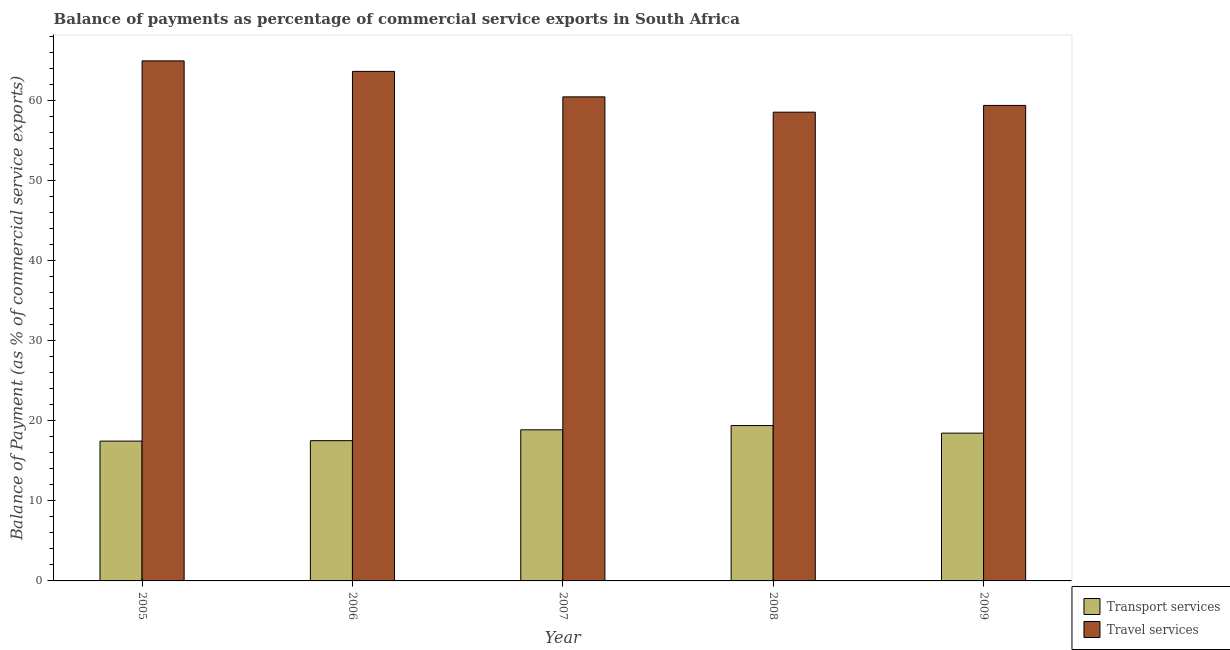Are the number of bars per tick equal to the number of legend labels?
Offer a very short reply. Yes. How many bars are there on the 4th tick from the right?
Offer a terse response. 2. What is the balance of payments of transport services in 2006?
Ensure brevity in your answer.  17.52. Across all years, what is the maximum balance of payments of travel services?
Ensure brevity in your answer.  64.96. Across all years, what is the minimum balance of payments of transport services?
Keep it short and to the point. 17.47. In which year was the balance of payments of travel services maximum?
Offer a terse response. 2005. What is the total balance of payments of travel services in the graph?
Your answer should be very brief. 307.03. What is the difference between the balance of payments of transport services in 2006 and that in 2009?
Make the answer very short. -0.94. What is the difference between the balance of payments of travel services in 2009 and the balance of payments of transport services in 2007?
Keep it short and to the point. -1.07. What is the average balance of payments of transport services per year?
Your response must be concise. 18.35. In the year 2009, what is the difference between the balance of payments of travel services and balance of payments of transport services?
Offer a very short reply. 0. In how many years, is the balance of payments of transport services greater than 10 %?
Provide a short and direct response. 5. What is the ratio of the balance of payments of travel services in 2005 to that in 2007?
Make the answer very short. 1.07. Is the balance of payments of travel services in 2006 less than that in 2008?
Keep it short and to the point. No. What is the difference between the highest and the second highest balance of payments of transport services?
Ensure brevity in your answer.  0.53. What is the difference between the highest and the lowest balance of payments of travel services?
Keep it short and to the point. 6.41. Is the sum of the balance of payments of travel services in 2005 and 2008 greater than the maximum balance of payments of transport services across all years?
Your answer should be compact. Yes. What does the 2nd bar from the left in 2005 represents?
Your response must be concise. Travel services. What does the 2nd bar from the right in 2005 represents?
Ensure brevity in your answer.  Transport services. What is the title of the graph?
Ensure brevity in your answer.  Balance of payments as percentage of commercial service exports in South Africa. Does "Diarrhea" appear as one of the legend labels in the graph?
Provide a succinct answer. No. What is the label or title of the X-axis?
Provide a short and direct response. Year. What is the label or title of the Y-axis?
Make the answer very short. Balance of Payment (as % of commercial service exports). What is the Balance of Payment (as % of commercial service exports) of Transport services in 2005?
Offer a very short reply. 17.47. What is the Balance of Payment (as % of commercial service exports) of Travel services in 2005?
Offer a very short reply. 64.96. What is the Balance of Payment (as % of commercial service exports) of Transport services in 2006?
Provide a succinct answer. 17.52. What is the Balance of Payment (as % of commercial service exports) of Travel services in 2006?
Your answer should be compact. 63.65. What is the Balance of Payment (as % of commercial service exports) of Transport services in 2007?
Make the answer very short. 18.88. What is the Balance of Payment (as % of commercial service exports) of Travel services in 2007?
Your answer should be very brief. 60.46. What is the Balance of Payment (as % of commercial service exports) in Transport services in 2008?
Offer a terse response. 19.41. What is the Balance of Payment (as % of commercial service exports) of Travel services in 2008?
Offer a terse response. 58.55. What is the Balance of Payment (as % of commercial service exports) in Transport services in 2009?
Provide a succinct answer. 18.46. What is the Balance of Payment (as % of commercial service exports) in Travel services in 2009?
Provide a short and direct response. 59.4. Across all years, what is the maximum Balance of Payment (as % of commercial service exports) in Transport services?
Give a very brief answer. 19.41. Across all years, what is the maximum Balance of Payment (as % of commercial service exports) of Travel services?
Your answer should be compact. 64.96. Across all years, what is the minimum Balance of Payment (as % of commercial service exports) in Transport services?
Your answer should be very brief. 17.47. Across all years, what is the minimum Balance of Payment (as % of commercial service exports) in Travel services?
Make the answer very short. 58.55. What is the total Balance of Payment (as % of commercial service exports) in Transport services in the graph?
Give a very brief answer. 91.73. What is the total Balance of Payment (as % of commercial service exports) in Travel services in the graph?
Make the answer very short. 307.03. What is the difference between the Balance of Payment (as % of commercial service exports) in Transport services in 2005 and that in 2006?
Ensure brevity in your answer.  -0.05. What is the difference between the Balance of Payment (as % of commercial service exports) in Travel services in 2005 and that in 2006?
Give a very brief answer. 1.31. What is the difference between the Balance of Payment (as % of commercial service exports) in Transport services in 2005 and that in 2007?
Keep it short and to the point. -1.41. What is the difference between the Balance of Payment (as % of commercial service exports) in Travel services in 2005 and that in 2007?
Your answer should be very brief. 4.5. What is the difference between the Balance of Payment (as % of commercial service exports) of Transport services in 2005 and that in 2008?
Offer a terse response. -1.94. What is the difference between the Balance of Payment (as % of commercial service exports) in Travel services in 2005 and that in 2008?
Provide a succinct answer. 6.41. What is the difference between the Balance of Payment (as % of commercial service exports) of Transport services in 2005 and that in 2009?
Your answer should be very brief. -0.99. What is the difference between the Balance of Payment (as % of commercial service exports) of Travel services in 2005 and that in 2009?
Keep it short and to the point. 5.56. What is the difference between the Balance of Payment (as % of commercial service exports) in Transport services in 2006 and that in 2007?
Make the answer very short. -1.36. What is the difference between the Balance of Payment (as % of commercial service exports) of Travel services in 2006 and that in 2007?
Make the answer very short. 3.18. What is the difference between the Balance of Payment (as % of commercial service exports) of Transport services in 2006 and that in 2008?
Your answer should be compact. -1.89. What is the difference between the Balance of Payment (as % of commercial service exports) in Travel services in 2006 and that in 2008?
Your answer should be compact. 5.1. What is the difference between the Balance of Payment (as % of commercial service exports) in Transport services in 2006 and that in 2009?
Your response must be concise. -0.94. What is the difference between the Balance of Payment (as % of commercial service exports) of Travel services in 2006 and that in 2009?
Provide a succinct answer. 4.25. What is the difference between the Balance of Payment (as % of commercial service exports) of Transport services in 2007 and that in 2008?
Provide a succinct answer. -0.53. What is the difference between the Balance of Payment (as % of commercial service exports) of Travel services in 2007 and that in 2008?
Your answer should be very brief. 1.91. What is the difference between the Balance of Payment (as % of commercial service exports) in Transport services in 2007 and that in 2009?
Offer a very short reply. 0.42. What is the difference between the Balance of Payment (as % of commercial service exports) of Travel services in 2007 and that in 2009?
Offer a terse response. 1.07. What is the difference between the Balance of Payment (as % of commercial service exports) in Transport services in 2008 and that in 2009?
Provide a short and direct response. 0.95. What is the difference between the Balance of Payment (as % of commercial service exports) of Travel services in 2008 and that in 2009?
Your answer should be compact. -0.84. What is the difference between the Balance of Payment (as % of commercial service exports) in Transport services in 2005 and the Balance of Payment (as % of commercial service exports) in Travel services in 2006?
Give a very brief answer. -46.18. What is the difference between the Balance of Payment (as % of commercial service exports) of Transport services in 2005 and the Balance of Payment (as % of commercial service exports) of Travel services in 2007?
Provide a succinct answer. -43. What is the difference between the Balance of Payment (as % of commercial service exports) in Transport services in 2005 and the Balance of Payment (as % of commercial service exports) in Travel services in 2008?
Offer a terse response. -41.09. What is the difference between the Balance of Payment (as % of commercial service exports) in Transport services in 2005 and the Balance of Payment (as % of commercial service exports) in Travel services in 2009?
Make the answer very short. -41.93. What is the difference between the Balance of Payment (as % of commercial service exports) of Transport services in 2006 and the Balance of Payment (as % of commercial service exports) of Travel services in 2007?
Your response must be concise. -42.95. What is the difference between the Balance of Payment (as % of commercial service exports) of Transport services in 2006 and the Balance of Payment (as % of commercial service exports) of Travel services in 2008?
Make the answer very short. -41.03. What is the difference between the Balance of Payment (as % of commercial service exports) in Transport services in 2006 and the Balance of Payment (as % of commercial service exports) in Travel services in 2009?
Provide a succinct answer. -41.88. What is the difference between the Balance of Payment (as % of commercial service exports) of Transport services in 2007 and the Balance of Payment (as % of commercial service exports) of Travel services in 2008?
Your response must be concise. -39.68. What is the difference between the Balance of Payment (as % of commercial service exports) in Transport services in 2007 and the Balance of Payment (as % of commercial service exports) in Travel services in 2009?
Provide a short and direct response. -40.52. What is the difference between the Balance of Payment (as % of commercial service exports) of Transport services in 2008 and the Balance of Payment (as % of commercial service exports) of Travel services in 2009?
Make the answer very short. -39.99. What is the average Balance of Payment (as % of commercial service exports) in Transport services per year?
Ensure brevity in your answer.  18.35. What is the average Balance of Payment (as % of commercial service exports) in Travel services per year?
Offer a terse response. 61.41. In the year 2005, what is the difference between the Balance of Payment (as % of commercial service exports) in Transport services and Balance of Payment (as % of commercial service exports) in Travel services?
Offer a terse response. -47.5. In the year 2006, what is the difference between the Balance of Payment (as % of commercial service exports) of Transport services and Balance of Payment (as % of commercial service exports) of Travel services?
Ensure brevity in your answer.  -46.13. In the year 2007, what is the difference between the Balance of Payment (as % of commercial service exports) of Transport services and Balance of Payment (as % of commercial service exports) of Travel services?
Keep it short and to the point. -41.59. In the year 2008, what is the difference between the Balance of Payment (as % of commercial service exports) in Transport services and Balance of Payment (as % of commercial service exports) in Travel services?
Offer a terse response. -39.15. In the year 2009, what is the difference between the Balance of Payment (as % of commercial service exports) of Transport services and Balance of Payment (as % of commercial service exports) of Travel services?
Make the answer very short. -40.94. What is the ratio of the Balance of Payment (as % of commercial service exports) of Travel services in 2005 to that in 2006?
Your answer should be compact. 1.02. What is the ratio of the Balance of Payment (as % of commercial service exports) of Transport services in 2005 to that in 2007?
Give a very brief answer. 0.93. What is the ratio of the Balance of Payment (as % of commercial service exports) in Travel services in 2005 to that in 2007?
Keep it short and to the point. 1.07. What is the ratio of the Balance of Payment (as % of commercial service exports) of Travel services in 2005 to that in 2008?
Your answer should be very brief. 1.11. What is the ratio of the Balance of Payment (as % of commercial service exports) of Transport services in 2005 to that in 2009?
Provide a succinct answer. 0.95. What is the ratio of the Balance of Payment (as % of commercial service exports) in Travel services in 2005 to that in 2009?
Offer a very short reply. 1.09. What is the ratio of the Balance of Payment (as % of commercial service exports) of Transport services in 2006 to that in 2007?
Give a very brief answer. 0.93. What is the ratio of the Balance of Payment (as % of commercial service exports) in Travel services in 2006 to that in 2007?
Ensure brevity in your answer.  1.05. What is the ratio of the Balance of Payment (as % of commercial service exports) of Transport services in 2006 to that in 2008?
Offer a very short reply. 0.9. What is the ratio of the Balance of Payment (as % of commercial service exports) in Travel services in 2006 to that in 2008?
Your answer should be compact. 1.09. What is the ratio of the Balance of Payment (as % of commercial service exports) in Transport services in 2006 to that in 2009?
Keep it short and to the point. 0.95. What is the ratio of the Balance of Payment (as % of commercial service exports) of Travel services in 2006 to that in 2009?
Give a very brief answer. 1.07. What is the ratio of the Balance of Payment (as % of commercial service exports) in Transport services in 2007 to that in 2008?
Your response must be concise. 0.97. What is the ratio of the Balance of Payment (as % of commercial service exports) in Travel services in 2007 to that in 2008?
Give a very brief answer. 1.03. What is the ratio of the Balance of Payment (as % of commercial service exports) in Transport services in 2007 to that in 2009?
Ensure brevity in your answer.  1.02. What is the ratio of the Balance of Payment (as % of commercial service exports) in Travel services in 2007 to that in 2009?
Your answer should be compact. 1.02. What is the ratio of the Balance of Payment (as % of commercial service exports) in Transport services in 2008 to that in 2009?
Offer a very short reply. 1.05. What is the ratio of the Balance of Payment (as % of commercial service exports) in Travel services in 2008 to that in 2009?
Offer a terse response. 0.99. What is the difference between the highest and the second highest Balance of Payment (as % of commercial service exports) in Transport services?
Your response must be concise. 0.53. What is the difference between the highest and the second highest Balance of Payment (as % of commercial service exports) of Travel services?
Keep it short and to the point. 1.31. What is the difference between the highest and the lowest Balance of Payment (as % of commercial service exports) in Transport services?
Make the answer very short. 1.94. What is the difference between the highest and the lowest Balance of Payment (as % of commercial service exports) in Travel services?
Ensure brevity in your answer.  6.41. 